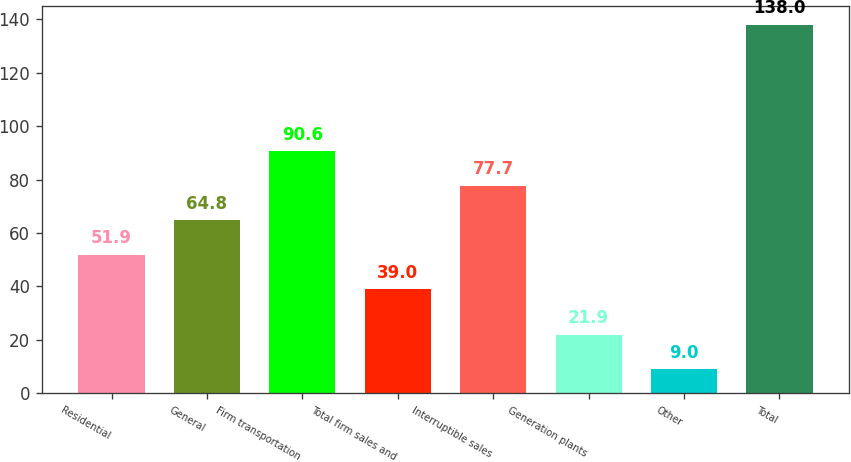<chart> <loc_0><loc_0><loc_500><loc_500><bar_chart><fcel>Residential<fcel>General<fcel>Firm transportation<fcel>Total firm sales and<fcel>Interruptible sales<fcel>Generation plants<fcel>Other<fcel>Total<nl><fcel>51.9<fcel>64.8<fcel>90.6<fcel>39<fcel>77.7<fcel>21.9<fcel>9<fcel>138<nl></chart> 